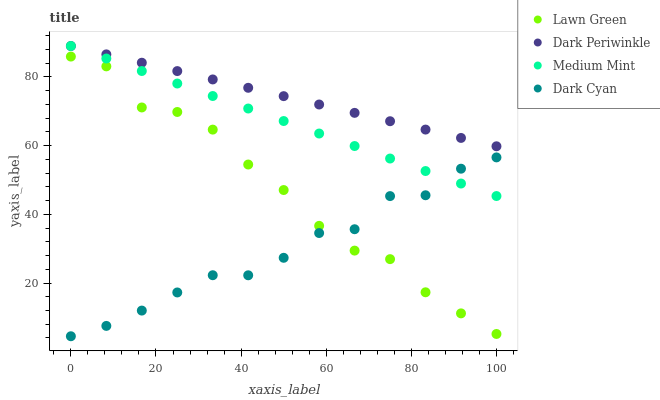Does Dark Cyan have the minimum area under the curve?
Answer yes or no. Yes. Does Dark Periwinkle have the maximum area under the curve?
Answer yes or no. Yes. Does Lawn Green have the minimum area under the curve?
Answer yes or no. No. Does Lawn Green have the maximum area under the curve?
Answer yes or no. No. Is Medium Mint the smoothest?
Answer yes or no. Yes. Is Lawn Green the roughest?
Answer yes or no. Yes. Is Dark Periwinkle the smoothest?
Answer yes or no. No. Is Dark Periwinkle the roughest?
Answer yes or no. No. Does Dark Cyan have the lowest value?
Answer yes or no. Yes. Does Lawn Green have the lowest value?
Answer yes or no. No. Does Dark Periwinkle have the highest value?
Answer yes or no. Yes. Does Lawn Green have the highest value?
Answer yes or no. No. Is Lawn Green less than Medium Mint?
Answer yes or no. Yes. Is Dark Periwinkle greater than Lawn Green?
Answer yes or no. Yes. Does Medium Mint intersect Dark Cyan?
Answer yes or no. Yes. Is Medium Mint less than Dark Cyan?
Answer yes or no. No. Is Medium Mint greater than Dark Cyan?
Answer yes or no. No. Does Lawn Green intersect Medium Mint?
Answer yes or no. No. 